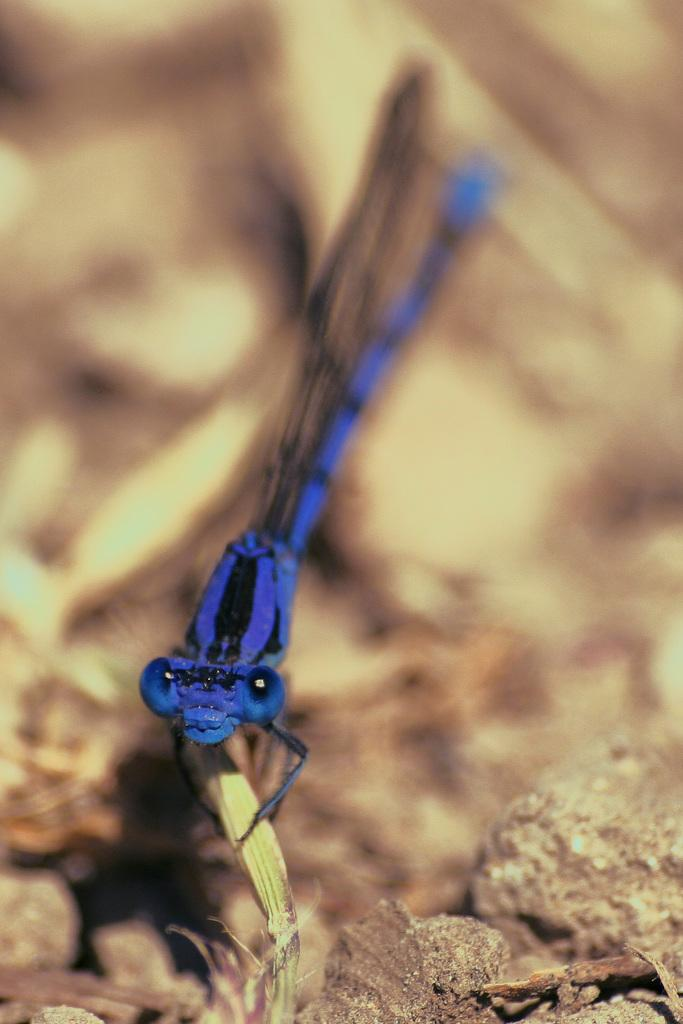What type of insect is present in the image? There is a blue color insect in the image. What other objects can be seen in the image? There are stones in the image. Can you describe the background of the image? The background of the image is blurred. Where is the coal being used in the image? There is no coal present in the image. What type of whip can be seen in the image? There is no whip present in the image. 